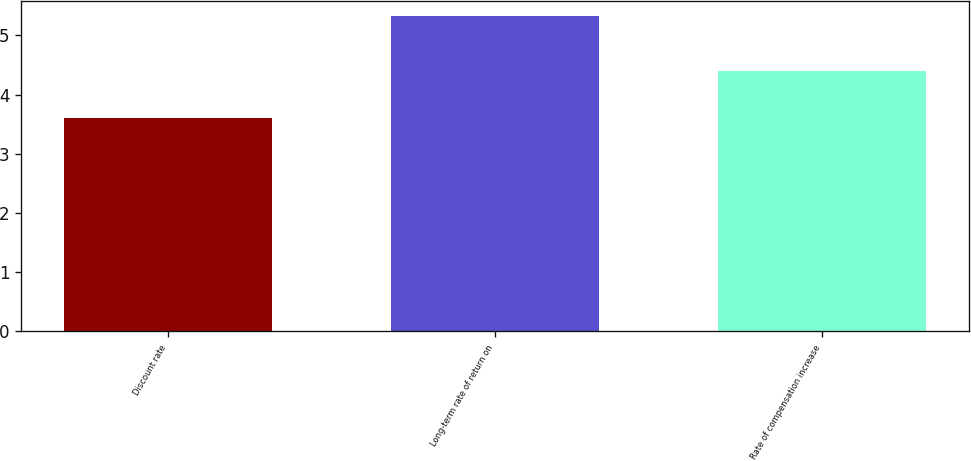Convert chart to OTSL. <chart><loc_0><loc_0><loc_500><loc_500><bar_chart><fcel>Discount rate<fcel>Long-term rate of return on<fcel>Rate of compensation increase<nl><fcel>3.6<fcel>5.32<fcel>4.4<nl></chart> 